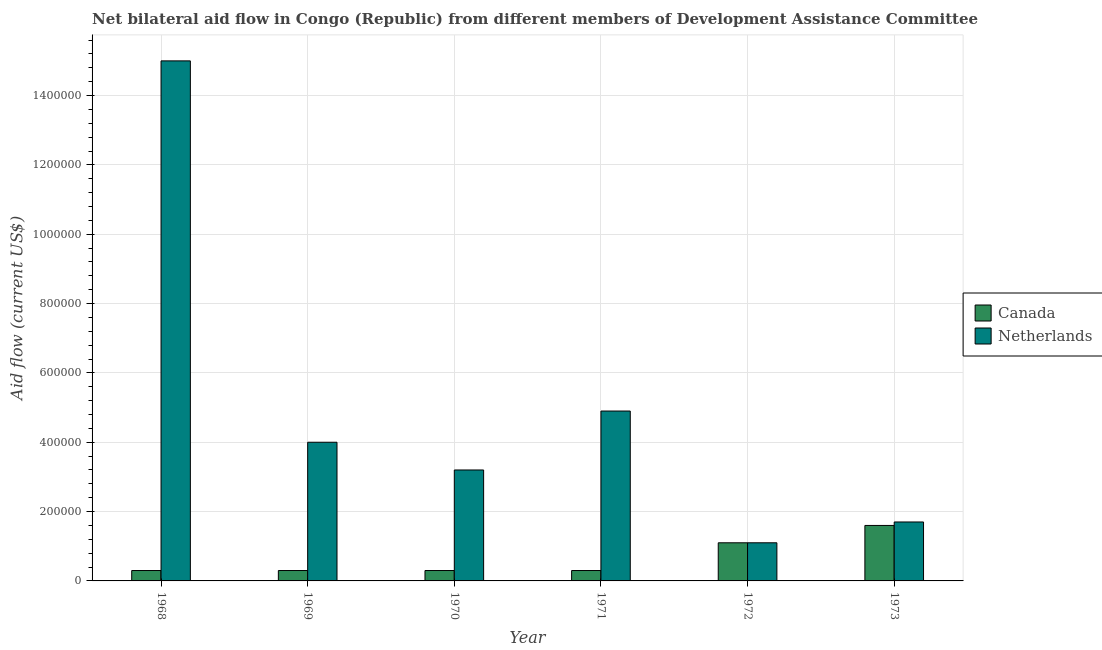How many different coloured bars are there?
Keep it short and to the point. 2. How many groups of bars are there?
Ensure brevity in your answer.  6. Are the number of bars per tick equal to the number of legend labels?
Make the answer very short. Yes. Are the number of bars on each tick of the X-axis equal?
Offer a very short reply. Yes. How many bars are there on the 1st tick from the right?
Your answer should be very brief. 2. What is the label of the 3rd group of bars from the left?
Offer a terse response. 1970. What is the amount of aid given by canada in 1970?
Ensure brevity in your answer.  3.00e+04. Across all years, what is the maximum amount of aid given by netherlands?
Offer a very short reply. 1.50e+06. Across all years, what is the minimum amount of aid given by canada?
Ensure brevity in your answer.  3.00e+04. In which year was the amount of aid given by netherlands maximum?
Your answer should be compact. 1968. In which year was the amount of aid given by canada minimum?
Make the answer very short. 1968. What is the total amount of aid given by canada in the graph?
Offer a very short reply. 3.90e+05. What is the difference between the amount of aid given by canada in 1969 and that in 1971?
Your response must be concise. 0. What is the difference between the amount of aid given by netherlands in 1973 and the amount of aid given by canada in 1968?
Offer a terse response. -1.33e+06. What is the average amount of aid given by canada per year?
Provide a short and direct response. 6.50e+04. In the year 1972, what is the difference between the amount of aid given by canada and amount of aid given by netherlands?
Ensure brevity in your answer.  0. What is the ratio of the amount of aid given by netherlands in 1968 to that in 1971?
Offer a very short reply. 3.06. What is the difference between the highest and the second highest amount of aid given by netherlands?
Offer a terse response. 1.01e+06. What is the difference between the highest and the lowest amount of aid given by canada?
Provide a short and direct response. 1.30e+05. In how many years, is the amount of aid given by canada greater than the average amount of aid given by canada taken over all years?
Your response must be concise. 2. What does the 2nd bar from the left in 1972 represents?
Your answer should be very brief. Netherlands. What does the 1st bar from the right in 1969 represents?
Give a very brief answer. Netherlands. Are all the bars in the graph horizontal?
Offer a very short reply. No. What is the difference between two consecutive major ticks on the Y-axis?
Give a very brief answer. 2.00e+05. Does the graph contain grids?
Provide a short and direct response. Yes. How many legend labels are there?
Your answer should be compact. 2. How are the legend labels stacked?
Give a very brief answer. Vertical. What is the title of the graph?
Make the answer very short. Net bilateral aid flow in Congo (Republic) from different members of Development Assistance Committee. What is the Aid flow (current US$) of Netherlands in 1968?
Your answer should be very brief. 1.50e+06. What is the Aid flow (current US$) in Netherlands in 1970?
Your answer should be very brief. 3.20e+05. What is the Aid flow (current US$) of Canada in 1971?
Keep it short and to the point. 3.00e+04. What is the Aid flow (current US$) in Netherlands in 1971?
Provide a short and direct response. 4.90e+05. What is the Aid flow (current US$) of Canada in 1972?
Keep it short and to the point. 1.10e+05. Across all years, what is the maximum Aid flow (current US$) in Canada?
Ensure brevity in your answer.  1.60e+05. Across all years, what is the maximum Aid flow (current US$) of Netherlands?
Give a very brief answer. 1.50e+06. Across all years, what is the minimum Aid flow (current US$) in Canada?
Make the answer very short. 3.00e+04. Across all years, what is the minimum Aid flow (current US$) in Netherlands?
Make the answer very short. 1.10e+05. What is the total Aid flow (current US$) in Netherlands in the graph?
Your answer should be very brief. 2.99e+06. What is the difference between the Aid flow (current US$) in Netherlands in 1968 and that in 1969?
Make the answer very short. 1.10e+06. What is the difference between the Aid flow (current US$) in Netherlands in 1968 and that in 1970?
Give a very brief answer. 1.18e+06. What is the difference between the Aid flow (current US$) in Canada in 1968 and that in 1971?
Make the answer very short. 0. What is the difference between the Aid flow (current US$) of Netherlands in 1968 and that in 1971?
Ensure brevity in your answer.  1.01e+06. What is the difference between the Aid flow (current US$) of Netherlands in 1968 and that in 1972?
Keep it short and to the point. 1.39e+06. What is the difference between the Aid flow (current US$) in Canada in 1968 and that in 1973?
Your answer should be compact. -1.30e+05. What is the difference between the Aid flow (current US$) of Netherlands in 1968 and that in 1973?
Your answer should be very brief. 1.33e+06. What is the difference between the Aid flow (current US$) of Netherlands in 1969 and that in 1970?
Give a very brief answer. 8.00e+04. What is the difference between the Aid flow (current US$) of Canada in 1969 and that in 1972?
Give a very brief answer. -8.00e+04. What is the difference between the Aid flow (current US$) of Canada in 1970 and that in 1971?
Your response must be concise. 0. What is the difference between the Aid flow (current US$) in Netherlands in 1970 and that in 1971?
Keep it short and to the point. -1.70e+05. What is the difference between the Aid flow (current US$) of Netherlands in 1970 and that in 1972?
Your answer should be compact. 2.10e+05. What is the difference between the Aid flow (current US$) in Canada in 1971 and that in 1972?
Provide a succinct answer. -8.00e+04. What is the difference between the Aid flow (current US$) of Netherlands in 1972 and that in 1973?
Make the answer very short. -6.00e+04. What is the difference between the Aid flow (current US$) of Canada in 1968 and the Aid flow (current US$) of Netherlands in 1969?
Offer a terse response. -3.70e+05. What is the difference between the Aid flow (current US$) of Canada in 1968 and the Aid flow (current US$) of Netherlands in 1970?
Your answer should be compact. -2.90e+05. What is the difference between the Aid flow (current US$) in Canada in 1968 and the Aid flow (current US$) in Netherlands in 1971?
Your response must be concise. -4.60e+05. What is the difference between the Aid flow (current US$) of Canada in 1968 and the Aid flow (current US$) of Netherlands in 1973?
Offer a very short reply. -1.40e+05. What is the difference between the Aid flow (current US$) of Canada in 1969 and the Aid flow (current US$) of Netherlands in 1971?
Make the answer very short. -4.60e+05. What is the difference between the Aid flow (current US$) of Canada in 1969 and the Aid flow (current US$) of Netherlands in 1973?
Ensure brevity in your answer.  -1.40e+05. What is the difference between the Aid flow (current US$) in Canada in 1970 and the Aid flow (current US$) in Netherlands in 1971?
Provide a short and direct response. -4.60e+05. What is the difference between the Aid flow (current US$) of Canada in 1970 and the Aid flow (current US$) of Netherlands in 1973?
Your answer should be compact. -1.40e+05. What is the difference between the Aid flow (current US$) of Canada in 1971 and the Aid flow (current US$) of Netherlands in 1972?
Give a very brief answer. -8.00e+04. What is the average Aid flow (current US$) in Canada per year?
Make the answer very short. 6.50e+04. What is the average Aid flow (current US$) of Netherlands per year?
Your answer should be compact. 4.98e+05. In the year 1968, what is the difference between the Aid flow (current US$) of Canada and Aid flow (current US$) of Netherlands?
Your answer should be very brief. -1.47e+06. In the year 1969, what is the difference between the Aid flow (current US$) in Canada and Aid flow (current US$) in Netherlands?
Your response must be concise. -3.70e+05. In the year 1970, what is the difference between the Aid flow (current US$) in Canada and Aid flow (current US$) in Netherlands?
Give a very brief answer. -2.90e+05. In the year 1971, what is the difference between the Aid flow (current US$) of Canada and Aid flow (current US$) of Netherlands?
Provide a succinct answer. -4.60e+05. In the year 1973, what is the difference between the Aid flow (current US$) of Canada and Aid flow (current US$) of Netherlands?
Keep it short and to the point. -10000. What is the ratio of the Aid flow (current US$) of Netherlands in 1968 to that in 1969?
Offer a terse response. 3.75. What is the ratio of the Aid flow (current US$) in Netherlands in 1968 to that in 1970?
Your answer should be very brief. 4.69. What is the ratio of the Aid flow (current US$) of Canada in 1968 to that in 1971?
Ensure brevity in your answer.  1. What is the ratio of the Aid flow (current US$) of Netherlands in 1968 to that in 1971?
Your response must be concise. 3.06. What is the ratio of the Aid flow (current US$) in Canada in 1968 to that in 1972?
Provide a short and direct response. 0.27. What is the ratio of the Aid flow (current US$) in Netherlands in 1968 to that in 1972?
Keep it short and to the point. 13.64. What is the ratio of the Aid flow (current US$) of Canada in 1968 to that in 1973?
Your answer should be compact. 0.19. What is the ratio of the Aid flow (current US$) in Netherlands in 1968 to that in 1973?
Your answer should be very brief. 8.82. What is the ratio of the Aid flow (current US$) in Netherlands in 1969 to that in 1971?
Offer a terse response. 0.82. What is the ratio of the Aid flow (current US$) of Canada in 1969 to that in 1972?
Make the answer very short. 0.27. What is the ratio of the Aid flow (current US$) of Netherlands in 1969 to that in 1972?
Provide a short and direct response. 3.64. What is the ratio of the Aid flow (current US$) in Canada in 1969 to that in 1973?
Keep it short and to the point. 0.19. What is the ratio of the Aid flow (current US$) in Netherlands in 1969 to that in 1973?
Your answer should be very brief. 2.35. What is the ratio of the Aid flow (current US$) of Netherlands in 1970 to that in 1971?
Provide a succinct answer. 0.65. What is the ratio of the Aid flow (current US$) in Canada in 1970 to that in 1972?
Provide a succinct answer. 0.27. What is the ratio of the Aid flow (current US$) in Netherlands in 1970 to that in 1972?
Keep it short and to the point. 2.91. What is the ratio of the Aid flow (current US$) in Canada in 1970 to that in 1973?
Offer a terse response. 0.19. What is the ratio of the Aid flow (current US$) in Netherlands in 1970 to that in 1973?
Your answer should be very brief. 1.88. What is the ratio of the Aid flow (current US$) of Canada in 1971 to that in 1972?
Make the answer very short. 0.27. What is the ratio of the Aid flow (current US$) of Netherlands in 1971 to that in 1972?
Provide a succinct answer. 4.45. What is the ratio of the Aid flow (current US$) in Canada in 1971 to that in 1973?
Give a very brief answer. 0.19. What is the ratio of the Aid flow (current US$) of Netherlands in 1971 to that in 1973?
Your answer should be compact. 2.88. What is the ratio of the Aid flow (current US$) in Canada in 1972 to that in 1973?
Offer a terse response. 0.69. What is the ratio of the Aid flow (current US$) in Netherlands in 1972 to that in 1973?
Your answer should be compact. 0.65. What is the difference between the highest and the second highest Aid flow (current US$) in Canada?
Ensure brevity in your answer.  5.00e+04. What is the difference between the highest and the second highest Aid flow (current US$) of Netherlands?
Provide a short and direct response. 1.01e+06. What is the difference between the highest and the lowest Aid flow (current US$) in Netherlands?
Provide a short and direct response. 1.39e+06. 